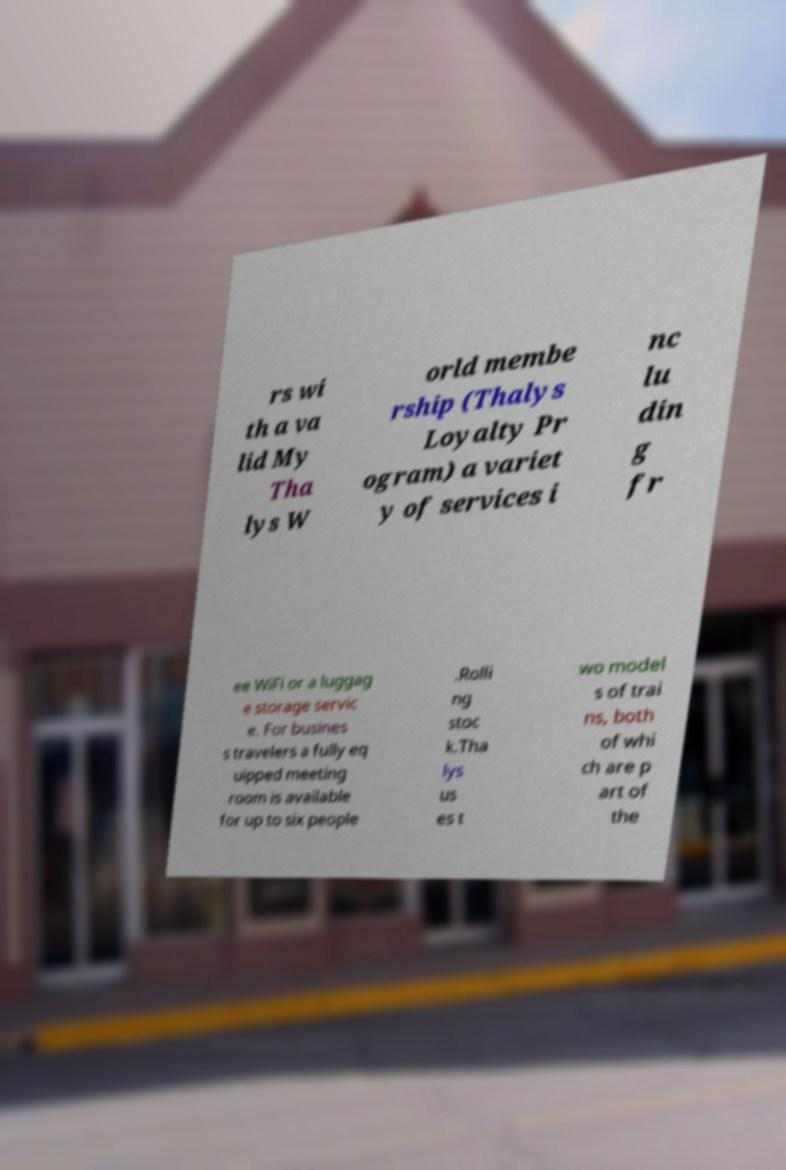Can you accurately transcribe the text from the provided image for me? rs wi th a va lid My Tha lys W orld membe rship (Thalys Loyalty Pr ogram) a variet y of services i nc lu din g fr ee WiFi or a luggag e storage servic e. For busines s travelers a fully eq uipped meeting room is available for up to six people .Rolli ng stoc k.Tha lys us es t wo model s of trai ns, both of whi ch are p art of the 